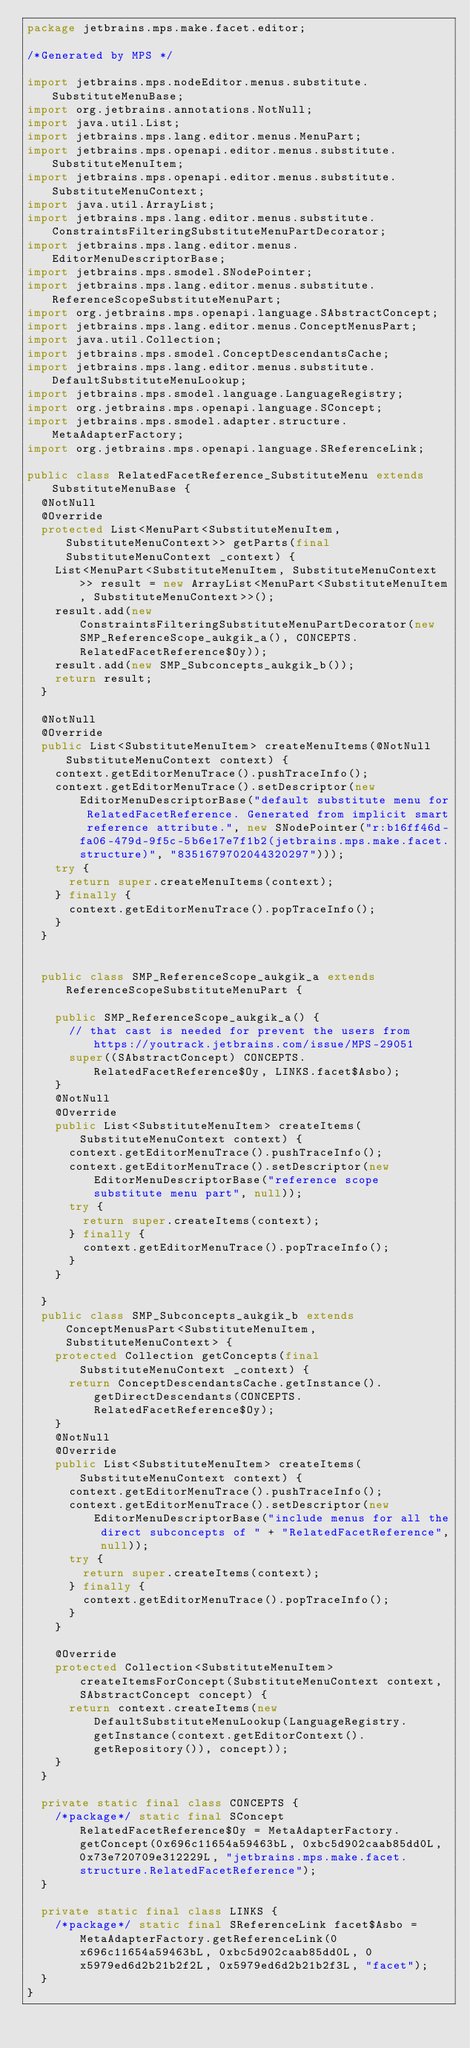<code> <loc_0><loc_0><loc_500><loc_500><_Java_>package jetbrains.mps.make.facet.editor;

/*Generated by MPS */

import jetbrains.mps.nodeEditor.menus.substitute.SubstituteMenuBase;
import org.jetbrains.annotations.NotNull;
import java.util.List;
import jetbrains.mps.lang.editor.menus.MenuPart;
import jetbrains.mps.openapi.editor.menus.substitute.SubstituteMenuItem;
import jetbrains.mps.openapi.editor.menus.substitute.SubstituteMenuContext;
import java.util.ArrayList;
import jetbrains.mps.lang.editor.menus.substitute.ConstraintsFilteringSubstituteMenuPartDecorator;
import jetbrains.mps.lang.editor.menus.EditorMenuDescriptorBase;
import jetbrains.mps.smodel.SNodePointer;
import jetbrains.mps.lang.editor.menus.substitute.ReferenceScopeSubstituteMenuPart;
import org.jetbrains.mps.openapi.language.SAbstractConcept;
import jetbrains.mps.lang.editor.menus.ConceptMenusPart;
import java.util.Collection;
import jetbrains.mps.smodel.ConceptDescendantsCache;
import jetbrains.mps.lang.editor.menus.substitute.DefaultSubstituteMenuLookup;
import jetbrains.mps.smodel.language.LanguageRegistry;
import org.jetbrains.mps.openapi.language.SConcept;
import jetbrains.mps.smodel.adapter.structure.MetaAdapterFactory;
import org.jetbrains.mps.openapi.language.SReferenceLink;

public class RelatedFacetReference_SubstituteMenu extends SubstituteMenuBase {
  @NotNull
  @Override
  protected List<MenuPart<SubstituteMenuItem, SubstituteMenuContext>> getParts(final SubstituteMenuContext _context) {
    List<MenuPart<SubstituteMenuItem, SubstituteMenuContext>> result = new ArrayList<MenuPart<SubstituteMenuItem, SubstituteMenuContext>>();
    result.add(new ConstraintsFilteringSubstituteMenuPartDecorator(new SMP_ReferenceScope_aukgik_a(), CONCEPTS.RelatedFacetReference$Oy));
    result.add(new SMP_Subconcepts_aukgik_b());
    return result;
  }

  @NotNull
  @Override
  public List<SubstituteMenuItem> createMenuItems(@NotNull SubstituteMenuContext context) {
    context.getEditorMenuTrace().pushTraceInfo();
    context.getEditorMenuTrace().setDescriptor(new EditorMenuDescriptorBase("default substitute menu for RelatedFacetReference. Generated from implicit smart reference attribute.", new SNodePointer("r:b16ff46d-fa06-479d-9f5c-5b6e17e7f1b2(jetbrains.mps.make.facet.structure)", "8351679702044320297")));
    try {
      return super.createMenuItems(context);
    } finally {
      context.getEditorMenuTrace().popTraceInfo();
    }
  }


  public class SMP_ReferenceScope_aukgik_a extends ReferenceScopeSubstituteMenuPart {

    public SMP_ReferenceScope_aukgik_a() {
      // that cast is needed for prevent the users from https://youtrack.jetbrains.com/issue/MPS-29051
      super((SAbstractConcept) CONCEPTS.RelatedFacetReference$Oy, LINKS.facet$Asbo);
    }
    @NotNull
    @Override
    public List<SubstituteMenuItem> createItems(SubstituteMenuContext context) {
      context.getEditorMenuTrace().pushTraceInfo();
      context.getEditorMenuTrace().setDescriptor(new EditorMenuDescriptorBase("reference scope substitute menu part", null));
      try {
        return super.createItems(context);
      } finally {
        context.getEditorMenuTrace().popTraceInfo();
      }
    }

  }
  public class SMP_Subconcepts_aukgik_b extends ConceptMenusPart<SubstituteMenuItem, SubstituteMenuContext> {
    protected Collection getConcepts(final SubstituteMenuContext _context) {
      return ConceptDescendantsCache.getInstance().getDirectDescendants(CONCEPTS.RelatedFacetReference$Oy);
    }
    @NotNull
    @Override
    public List<SubstituteMenuItem> createItems(SubstituteMenuContext context) {
      context.getEditorMenuTrace().pushTraceInfo();
      context.getEditorMenuTrace().setDescriptor(new EditorMenuDescriptorBase("include menus for all the direct subconcepts of " + "RelatedFacetReference", null));
      try {
        return super.createItems(context);
      } finally {
        context.getEditorMenuTrace().popTraceInfo();
      }
    }

    @Override
    protected Collection<SubstituteMenuItem> createItemsForConcept(SubstituteMenuContext context, SAbstractConcept concept) {
      return context.createItems(new DefaultSubstituteMenuLookup(LanguageRegistry.getInstance(context.getEditorContext().getRepository()), concept));
    }
  }

  private static final class CONCEPTS {
    /*package*/ static final SConcept RelatedFacetReference$Oy = MetaAdapterFactory.getConcept(0x696c11654a59463bL, 0xbc5d902caab85dd0L, 0x73e720709e312229L, "jetbrains.mps.make.facet.structure.RelatedFacetReference");
  }

  private static final class LINKS {
    /*package*/ static final SReferenceLink facet$Asbo = MetaAdapterFactory.getReferenceLink(0x696c11654a59463bL, 0xbc5d902caab85dd0L, 0x5979ed6d2b21b2f2L, 0x5979ed6d2b21b2f3L, "facet");
  }
}
</code> 